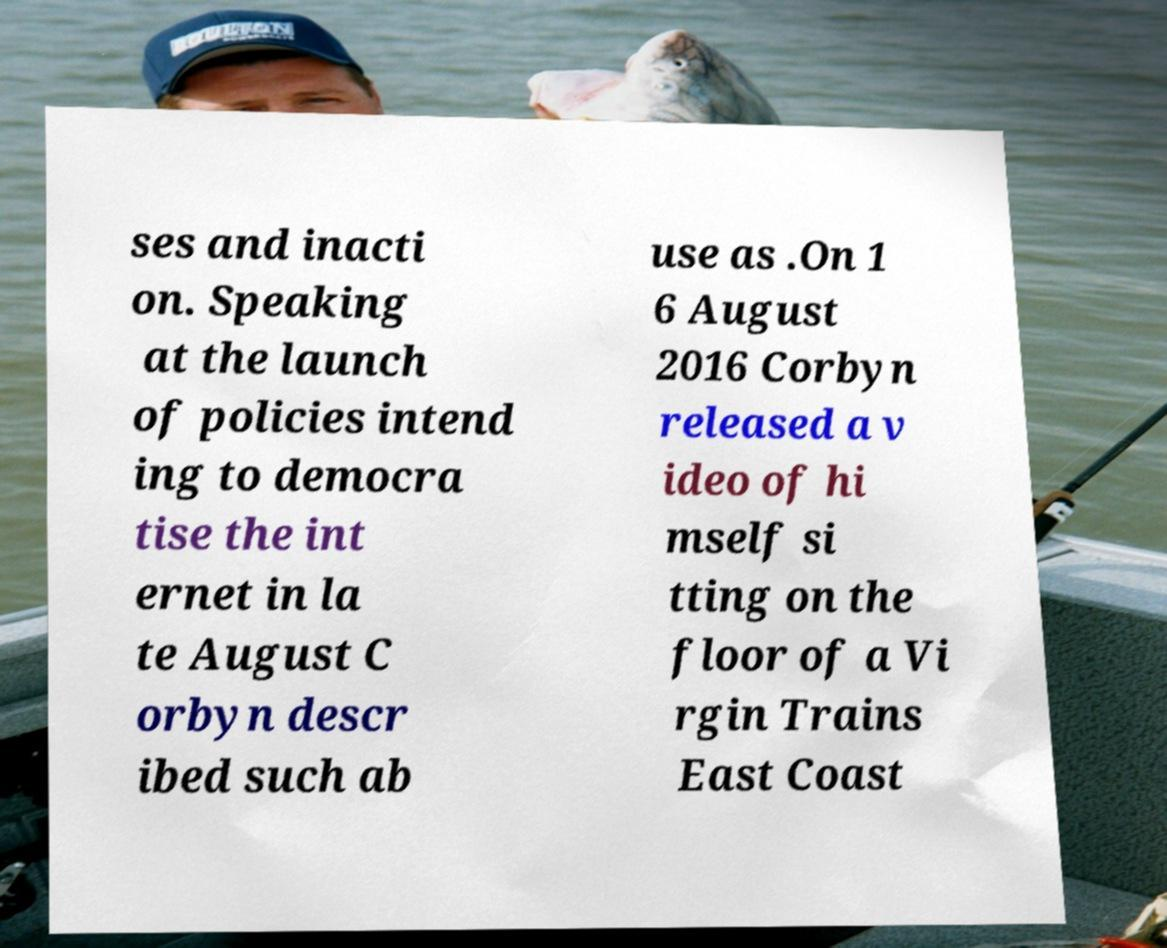Can you accurately transcribe the text from the provided image for me? ses and inacti on. Speaking at the launch of policies intend ing to democra tise the int ernet in la te August C orbyn descr ibed such ab use as .On 1 6 August 2016 Corbyn released a v ideo of hi mself si tting on the floor of a Vi rgin Trains East Coast 